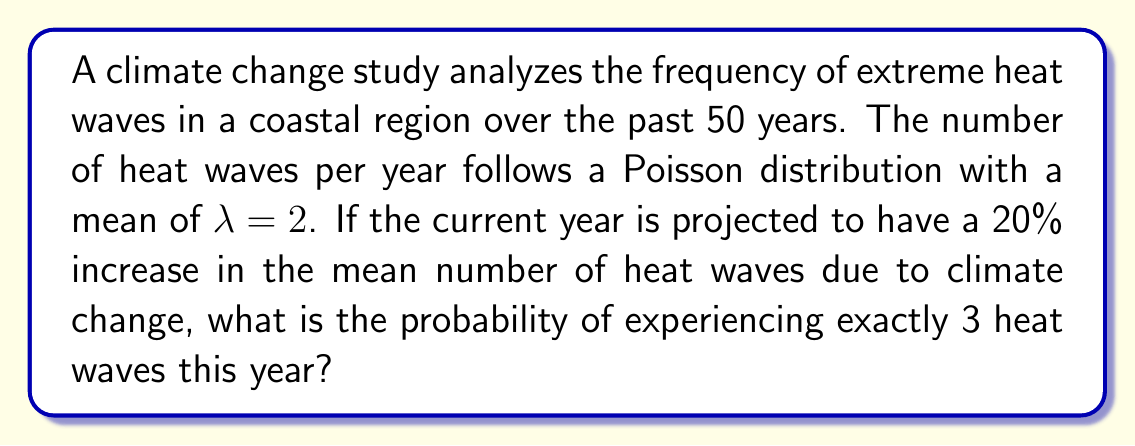Give your solution to this math problem. Let's approach this step-by-step:

1) The original Poisson distribution has a mean of λ = 2 heat waves per year.

2) With a 20% increase, the new mean is:
   $\lambda_{new} = 2 \times 1.20 = 2.4$ heat waves per year

3) The probability mass function for a Poisson distribution is:

   $P(X = k) = \frac{e^{-\lambda} \lambda^k}{k!}$

   where $k$ is the number of events (in this case, heat waves) and $\lambda$ is the mean.

4) We want to find $P(X = 3)$ with $\lambda = 2.4$:

   $P(X = 3) = \frac{e^{-2.4} (2.4)^3}{3!}$

5) Let's calculate this step-by-step:
   
   $e^{-2.4} \approx 0.0907$
   
   $(2.4)^3 = 13.824$
   
   $3! = 6$

   $\frac{0.0907 \times 13.824}{6} \approx 0.2090$

6) Therefore, the probability of experiencing exactly 3 heat waves in the current year is approximately 0.2090 or 20.90%.
Answer: 0.2090 